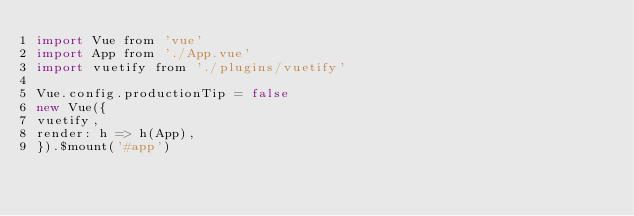<code> <loc_0><loc_0><loc_500><loc_500><_JavaScript_>import Vue from 'vue'
import App from './App.vue'
import vuetify from './plugins/vuetify'

Vue.config.productionTip = false
new Vue({
vuetify,
render: h => h(App),
}).$mount('#app')
</code> 